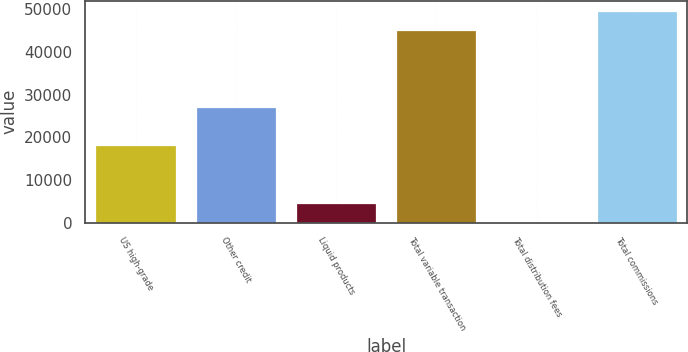Convert chart. <chart><loc_0><loc_0><loc_500><loc_500><bar_chart><fcel>US high-grade<fcel>Other credit<fcel>Liquid products<fcel>Total variable transaction<fcel>Total distribution fees<fcel>Total commissions<nl><fcel>18137<fcel>27140<fcel>4554.2<fcel>45032<fcel>51<fcel>49535.2<nl></chart> 